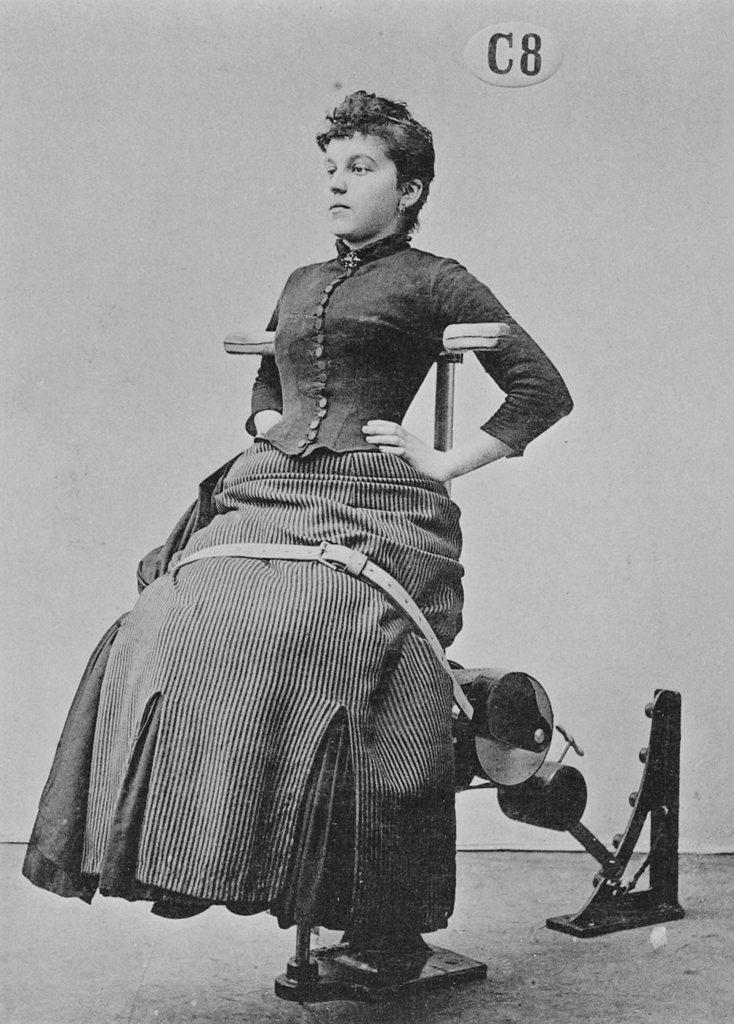What is the color scheme of the image? The image is black and white. What is the person in the image doing? The person is sitting on a supporting chair. What can be seen in the background of the image? There is a board attached to the wall in the background. How many nails are visible on the person's hand in the image? There are no nails visible on the person's hand in the image. 